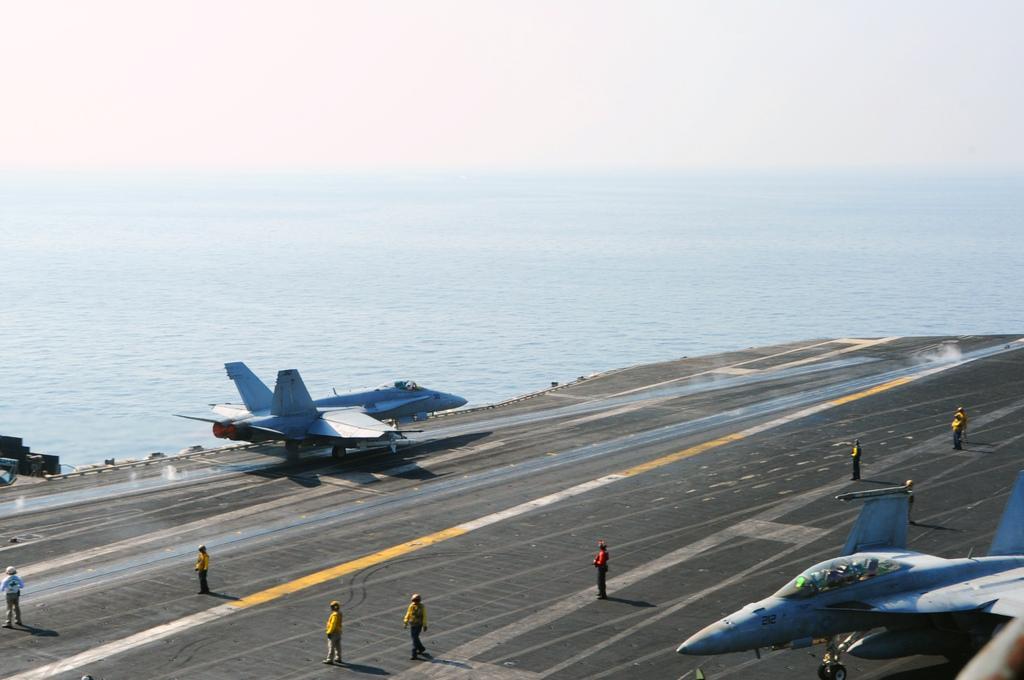In one or two sentences, can you explain what this image depicts? In this picture there are people and aircraft at the bottom side of the image and there is water in the background area of the image. 